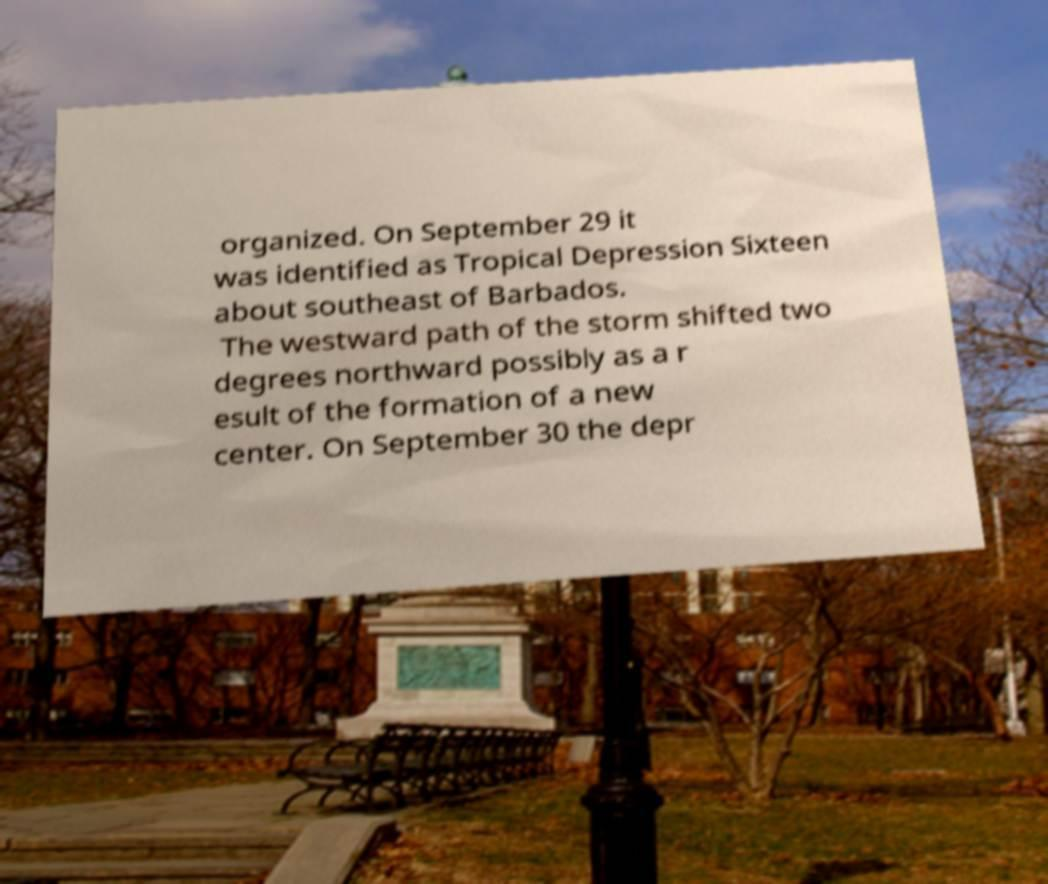Could you assist in decoding the text presented in this image and type it out clearly? organized. On September 29 it was identified as Tropical Depression Sixteen about southeast of Barbados. The westward path of the storm shifted two degrees northward possibly as a r esult of the formation of a new center. On September 30 the depr 